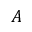<formula> <loc_0><loc_0><loc_500><loc_500>A</formula> 